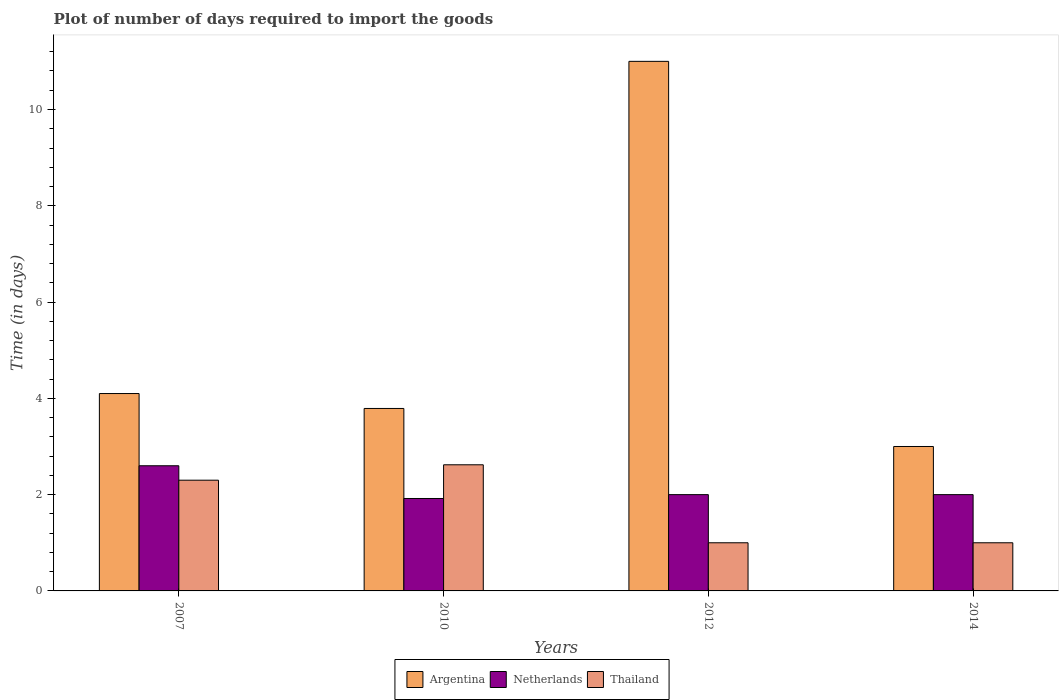How many different coloured bars are there?
Your response must be concise. 3. Are the number of bars per tick equal to the number of legend labels?
Provide a succinct answer. Yes. How many bars are there on the 3rd tick from the left?
Ensure brevity in your answer.  3. In how many cases, is the number of bars for a given year not equal to the number of legend labels?
Your answer should be very brief. 0. What is the time required to import goods in Netherlands in 2007?
Your answer should be compact. 2.6. Across all years, what is the maximum time required to import goods in Netherlands?
Ensure brevity in your answer.  2.6. Across all years, what is the minimum time required to import goods in Thailand?
Keep it short and to the point. 1. In which year was the time required to import goods in Netherlands maximum?
Provide a short and direct response. 2007. What is the total time required to import goods in Argentina in the graph?
Your answer should be compact. 21.89. What is the difference between the time required to import goods in Thailand in 2007 and that in 2012?
Your answer should be very brief. 1.3. What is the difference between the time required to import goods in Argentina in 2010 and the time required to import goods in Thailand in 2012?
Your response must be concise. 2.79. What is the average time required to import goods in Netherlands per year?
Give a very brief answer. 2.13. In the year 2010, what is the difference between the time required to import goods in Argentina and time required to import goods in Netherlands?
Make the answer very short. 1.87. What is the ratio of the time required to import goods in Thailand in 2010 to that in 2012?
Keep it short and to the point. 2.62. Is the time required to import goods in Netherlands in 2010 less than that in 2012?
Keep it short and to the point. Yes. Is the difference between the time required to import goods in Argentina in 2010 and 2012 greater than the difference between the time required to import goods in Netherlands in 2010 and 2012?
Your answer should be compact. No. What is the difference between the highest and the second highest time required to import goods in Netherlands?
Your answer should be very brief. 0.6. What is the difference between the highest and the lowest time required to import goods in Thailand?
Your answer should be compact. 1.62. In how many years, is the time required to import goods in Thailand greater than the average time required to import goods in Thailand taken over all years?
Give a very brief answer. 2. Is the sum of the time required to import goods in Netherlands in 2012 and 2014 greater than the maximum time required to import goods in Thailand across all years?
Offer a very short reply. Yes. What does the 1st bar from the left in 2014 represents?
Provide a short and direct response. Argentina. What does the 2nd bar from the right in 2010 represents?
Your answer should be very brief. Netherlands. Are all the bars in the graph horizontal?
Your answer should be compact. No. How many years are there in the graph?
Offer a very short reply. 4. What is the difference between two consecutive major ticks on the Y-axis?
Ensure brevity in your answer.  2. Where does the legend appear in the graph?
Your answer should be very brief. Bottom center. How are the legend labels stacked?
Your answer should be compact. Horizontal. What is the title of the graph?
Give a very brief answer. Plot of number of days required to import the goods. What is the label or title of the X-axis?
Your answer should be compact. Years. What is the label or title of the Y-axis?
Offer a very short reply. Time (in days). What is the Time (in days) of Argentina in 2007?
Make the answer very short. 4.1. What is the Time (in days) of Netherlands in 2007?
Your answer should be very brief. 2.6. What is the Time (in days) in Argentina in 2010?
Give a very brief answer. 3.79. What is the Time (in days) in Netherlands in 2010?
Give a very brief answer. 1.92. What is the Time (in days) of Thailand in 2010?
Give a very brief answer. 2.62. What is the Time (in days) of Netherlands in 2012?
Your response must be concise. 2. What is the Time (in days) in Thailand in 2012?
Give a very brief answer. 1. What is the Time (in days) in Thailand in 2014?
Your response must be concise. 1. Across all years, what is the maximum Time (in days) of Thailand?
Provide a short and direct response. 2.62. Across all years, what is the minimum Time (in days) in Netherlands?
Your answer should be very brief. 1.92. What is the total Time (in days) of Argentina in the graph?
Provide a succinct answer. 21.89. What is the total Time (in days) in Netherlands in the graph?
Your response must be concise. 8.52. What is the total Time (in days) of Thailand in the graph?
Offer a very short reply. 6.92. What is the difference between the Time (in days) in Argentina in 2007 and that in 2010?
Offer a terse response. 0.31. What is the difference between the Time (in days) in Netherlands in 2007 and that in 2010?
Your answer should be very brief. 0.68. What is the difference between the Time (in days) of Thailand in 2007 and that in 2010?
Give a very brief answer. -0.32. What is the difference between the Time (in days) of Argentina in 2007 and that in 2012?
Make the answer very short. -6.9. What is the difference between the Time (in days) of Netherlands in 2007 and that in 2012?
Offer a very short reply. 0.6. What is the difference between the Time (in days) in Thailand in 2007 and that in 2012?
Offer a very short reply. 1.3. What is the difference between the Time (in days) in Argentina in 2007 and that in 2014?
Give a very brief answer. 1.1. What is the difference between the Time (in days) of Netherlands in 2007 and that in 2014?
Give a very brief answer. 0.6. What is the difference between the Time (in days) of Argentina in 2010 and that in 2012?
Your answer should be compact. -7.21. What is the difference between the Time (in days) of Netherlands in 2010 and that in 2012?
Provide a short and direct response. -0.08. What is the difference between the Time (in days) of Thailand in 2010 and that in 2012?
Make the answer very short. 1.62. What is the difference between the Time (in days) in Argentina in 2010 and that in 2014?
Provide a short and direct response. 0.79. What is the difference between the Time (in days) in Netherlands in 2010 and that in 2014?
Provide a succinct answer. -0.08. What is the difference between the Time (in days) in Thailand in 2010 and that in 2014?
Offer a very short reply. 1.62. What is the difference between the Time (in days) in Argentina in 2012 and that in 2014?
Give a very brief answer. 8. What is the difference between the Time (in days) of Netherlands in 2012 and that in 2014?
Your response must be concise. 0. What is the difference between the Time (in days) in Thailand in 2012 and that in 2014?
Provide a succinct answer. 0. What is the difference between the Time (in days) of Argentina in 2007 and the Time (in days) of Netherlands in 2010?
Your answer should be compact. 2.18. What is the difference between the Time (in days) in Argentina in 2007 and the Time (in days) in Thailand in 2010?
Your response must be concise. 1.48. What is the difference between the Time (in days) of Netherlands in 2007 and the Time (in days) of Thailand in 2010?
Your answer should be compact. -0.02. What is the difference between the Time (in days) of Argentina in 2007 and the Time (in days) of Netherlands in 2012?
Offer a very short reply. 2.1. What is the difference between the Time (in days) of Argentina in 2007 and the Time (in days) of Thailand in 2012?
Keep it short and to the point. 3.1. What is the difference between the Time (in days) in Netherlands in 2007 and the Time (in days) in Thailand in 2012?
Ensure brevity in your answer.  1.6. What is the difference between the Time (in days) of Argentina in 2007 and the Time (in days) of Netherlands in 2014?
Offer a very short reply. 2.1. What is the difference between the Time (in days) in Argentina in 2007 and the Time (in days) in Thailand in 2014?
Provide a succinct answer. 3.1. What is the difference between the Time (in days) of Argentina in 2010 and the Time (in days) of Netherlands in 2012?
Your response must be concise. 1.79. What is the difference between the Time (in days) of Argentina in 2010 and the Time (in days) of Thailand in 2012?
Make the answer very short. 2.79. What is the difference between the Time (in days) of Argentina in 2010 and the Time (in days) of Netherlands in 2014?
Your response must be concise. 1.79. What is the difference between the Time (in days) of Argentina in 2010 and the Time (in days) of Thailand in 2014?
Offer a very short reply. 2.79. What is the difference between the Time (in days) in Netherlands in 2010 and the Time (in days) in Thailand in 2014?
Offer a terse response. 0.92. What is the difference between the Time (in days) of Argentina in 2012 and the Time (in days) of Netherlands in 2014?
Give a very brief answer. 9. What is the average Time (in days) in Argentina per year?
Provide a succinct answer. 5.47. What is the average Time (in days) of Netherlands per year?
Ensure brevity in your answer.  2.13. What is the average Time (in days) in Thailand per year?
Keep it short and to the point. 1.73. In the year 2007, what is the difference between the Time (in days) in Argentina and Time (in days) in Netherlands?
Offer a very short reply. 1.5. In the year 2007, what is the difference between the Time (in days) of Netherlands and Time (in days) of Thailand?
Give a very brief answer. 0.3. In the year 2010, what is the difference between the Time (in days) of Argentina and Time (in days) of Netherlands?
Keep it short and to the point. 1.87. In the year 2010, what is the difference between the Time (in days) of Argentina and Time (in days) of Thailand?
Provide a short and direct response. 1.17. In the year 2010, what is the difference between the Time (in days) in Netherlands and Time (in days) in Thailand?
Give a very brief answer. -0.7. In the year 2012, what is the difference between the Time (in days) in Argentina and Time (in days) in Thailand?
Provide a succinct answer. 10. In the year 2012, what is the difference between the Time (in days) of Netherlands and Time (in days) of Thailand?
Offer a very short reply. 1. What is the ratio of the Time (in days) in Argentina in 2007 to that in 2010?
Give a very brief answer. 1.08. What is the ratio of the Time (in days) of Netherlands in 2007 to that in 2010?
Your answer should be very brief. 1.35. What is the ratio of the Time (in days) of Thailand in 2007 to that in 2010?
Give a very brief answer. 0.88. What is the ratio of the Time (in days) of Argentina in 2007 to that in 2012?
Offer a terse response. 0.37. What is the ratio of the Time (in days) in Netherlands in 2007 to that in 2012?
Offer a terse response. 1.3. What is the ratio of the Time (in days) of Thailand in 2007 to that in 2012?
Provide a succinct answer. 2.3. What is the ratio of the Time (in days) in Argentina in 2007 to that in 2014?
Make the answer very short. 1.37. What is the ratio of the Time (in days) in Argentina in 2010 to that in 2012?
Offer a very short reply. 0.34. What is the ratio of the Time (in days) of Thailand in 2010 to that in 2012?
Offer a very short reply. 2.62. What is the ratio of the Time (in days) in Argentina in 2010 to that in 2014?
Keep it short and to the point. 1.26. What is the ratio of the Time (in days) in Thailand in 2010 to that in 2014?
Provide a succinct answer. 2.62. What is the ratio of the Time (in days) in Argentina in 2012 to that in 2014?
Your answer should be very brief. 3.67. What is the ratio of the Time (in days) in Thailand in 2012 to that in 2014?
Your answer should be compact. 1. What is the difference between the highest and the second highest Time (in days) in Thailand?
Make the answer very short. 0.32. What is the difference between the highest and the lowest Time (in days) of Netherlands?
Give a very brief answer. 0.68. What is the difference between the highest and the lowest Time (in days) in Thailand?
Offer a terse response. 1.62. 